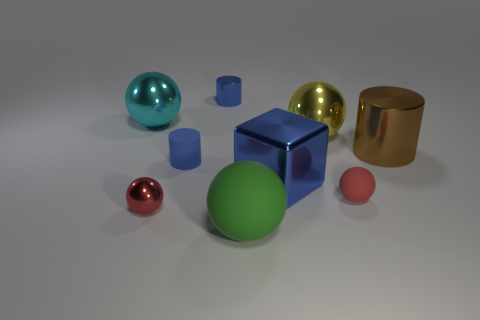There is a sphere that is behind the small metal sphere and to the left of the big green matte ball; how big is it?
Make the answer very short. Large. There is a rubber cylinder that is the same color as the block; what is its size?
Ensure brevity in your answer.  Small. How many objects are either rubber balls or red cylinders?
Offer a very short reply. 2. There is a shiny cylinder that is the same size as the green object; what color is it?
Your answer should be very brief. Brown. There is a cyan thing; is it the same shape as the matte thing that is on the right side of the green ball?
Provide a succinct answer. Yes. How many things are things behind the rubber cylinder or metallic cylinders in front of the yellow metal sphere?
Your answer should be compact. 4. What is the shape of the tiny metal object that is the same color as the big metallic cube?
Make the answer very short. Cylinder. There is a red object on the left side of the green matte object; what is its shape?
Your response must be concise. Sphere. Does the large yellow object behind the small blue rubber cylinder have the same shape as the large brown thing?
Give a very brief answer. No. How many objects are tiny shiny objects behind the large cyan object or cyan metallic blocks?
Your answer should be very brief. 1. 